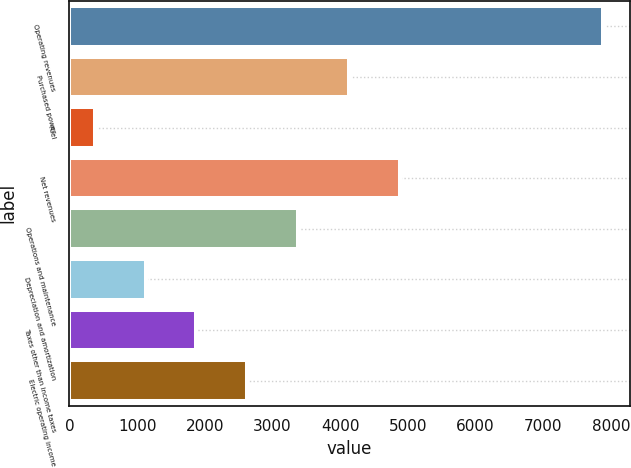Convert chart to OTSL. <chart><loc_0><loc_0><loc_500><loc_500><bar_chart><fcel>Operating revenues<fcel>Purchased power<fcel>Fuel<fcel>Net revenues<fcel>Operations and maintenance<fcel>Depreciation and amortization<fcel>Taxes other than income taxes<fcel>Electric operating income<nl><fcel>7878<fcel>4127<fcel>376<fcel>4877.2<fcel>3376.8<fcel>1126.2<fcel>1876.4<fcel>2626.6<nl></chart> 